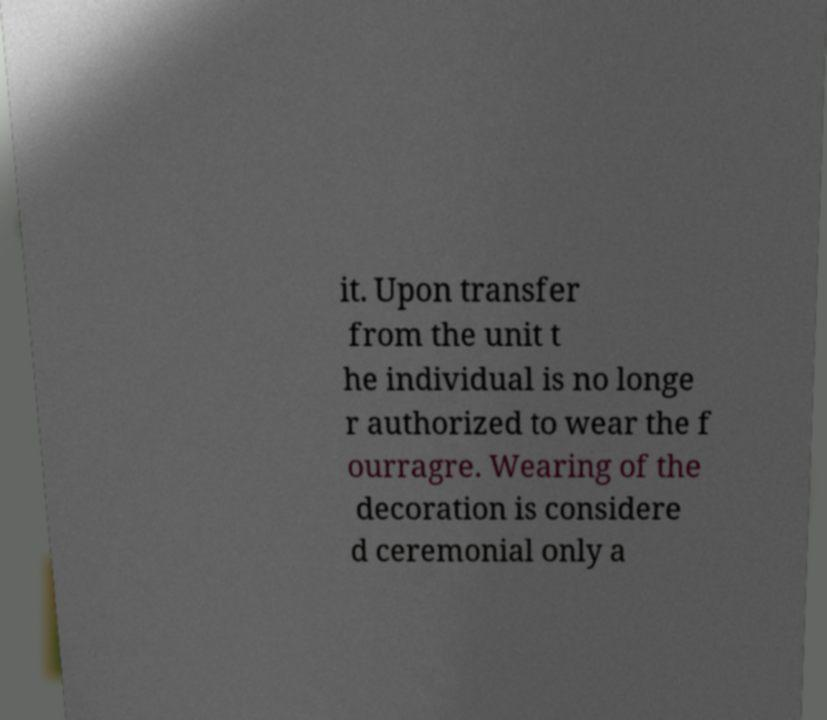What messages or text are displayed in this image? I need them in a readable, typed format. it. Upon transfer from the unit t he individual is no longe r authorized to wear the f ourragre. Wearing of the decoration is considere d ceremonial only a 